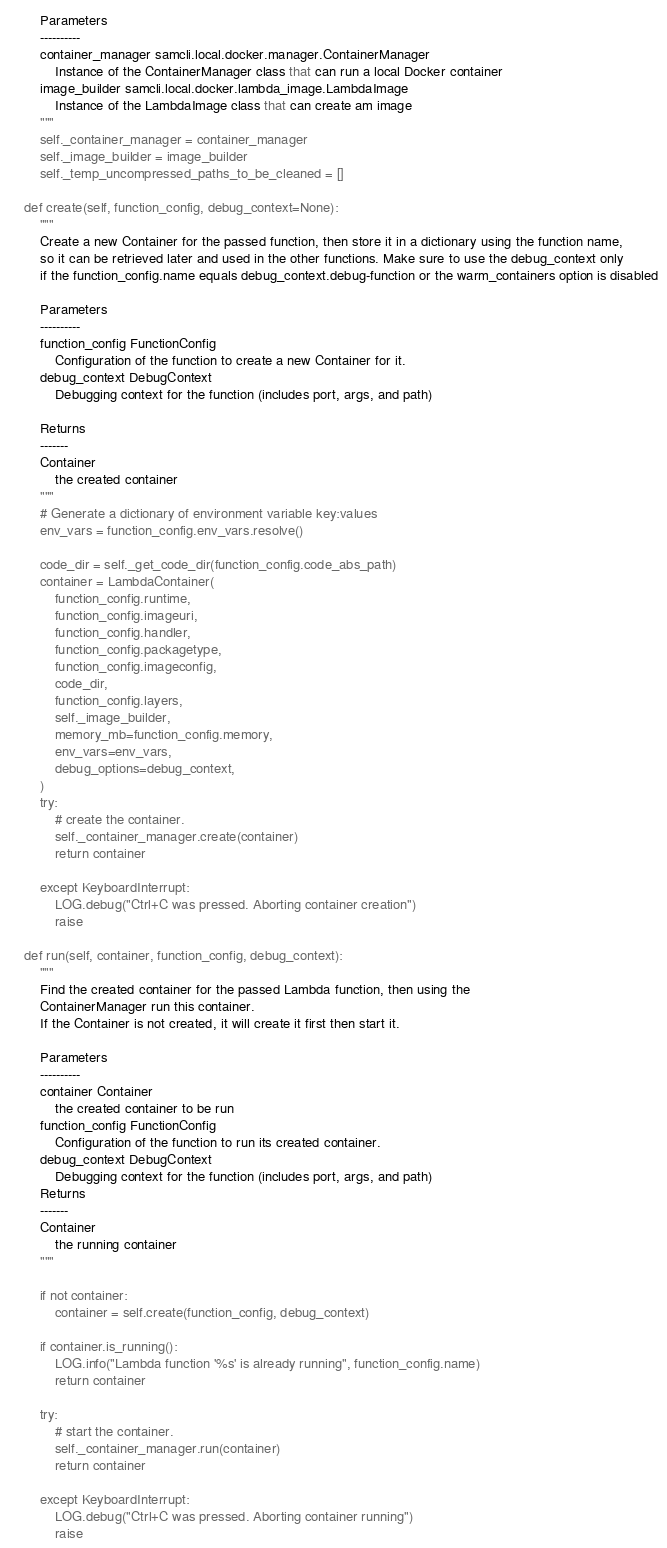<code> <loc_0><loc_0><loc_500><loc_500><_Python_>
        Parameters
        ----------
        container_manager samcli.local.docker.manager.ContainerManager
            Instance of the ContainerManager class that can run a local Docker container
        image_builder samcli.local.docker.lambda_image.LambdaImage
            Instance of the LambdaImage class that can create am image
        """
        self._container_manager = container_manager
        self._image_builder = image_builder
        self._temp_uncompressed_paths_to_be_cleaned = []

    def create(self, function_config, debug_context=None):
        """
        Create a new Container for the passed function, then store it in a dictionary using the function name,
        so it can be retrieved later and used in the other functions. Make sure to use the debug_context only
        if the function_config.name equals debug_context.debug-function or the warm_containers option is disabled

        Parameters
        ----------
        function_config FunctionConfig
            Configuration of the function to create a new Container for it.
        debug_context DebugContext
            Debugging context for the function (includes port, args, and path)

        Returns
        -------
        Container
            the created container
        """
        # Generate a dictionary of environment variable key:values
        env_vars = function_config.env_vars.resolve()

        code_dir = self._get_code_dir(function_config.code_abs_path)
        container = LambdaContainer(
            function_config.runtime,
            function_config.imageuri,
            function_config.handler,
            function_config.packagetype,
            function_config.imageconfig,
            code_dir,
            function_config.layers,
            self._image_builder,
            memory_mb=function_config.memory,
            env_vars=env_vars,
            debug_options=debug_context,
        )
        try:
            # create the container.
            self._container_manager.create(container)
            return container

        except KeyboardInterrupt:
            LOG.debug("Ctrl+C was pressed. Aborting container creation")
            raise

    def run(self, container, function_config, debug_context):
        """
        Find the created container for the passed Lambda function, then using the
        ContainerManager run this container.
        If the Container is not created, it will create it first then start it.

        Parameters
        ----------
        container Container
            the created container to be run
        function_config FunctionConfig
            Configuration of the function to run its created container.
        debug_context DebugContext
            Debugging context for the function (includes port, args, and path)
        Returns
        -------
        Container
            the running container
        """

        if not container:
            container = self.create(function_config, debug_context)

        if container.is_running():
            LOG.info("Lambda function '%s' is already running", function_config.name)
            return container

        try:
            # start the container.
            self._container_manager.run(container)
            return container

        except KeyboardInterrupt:
            LOG.debug("Ctrl+C was pressed. Aborting container running")
            raise
</code> 